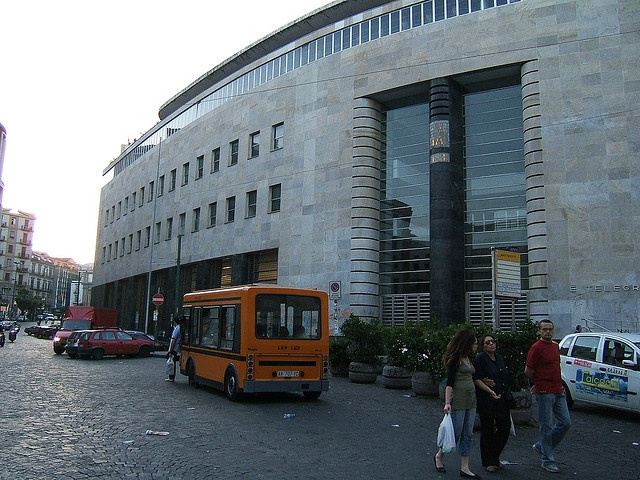Describe the objects in this image and their specific colors. I can see bus in white, black, maroon, and gray tones, car in white, black, gray, and blue tones, people in white, black, darkblue, gray, and blue tones, people in white, black, darkblue, maroon, and gray tones, and people in white, black, and gray tones in this image. 